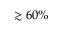Convert formula to latex. <formula><loc_0><loc_0><loc_500><loc_500>\gtrsim 6 0 \%</formula> 